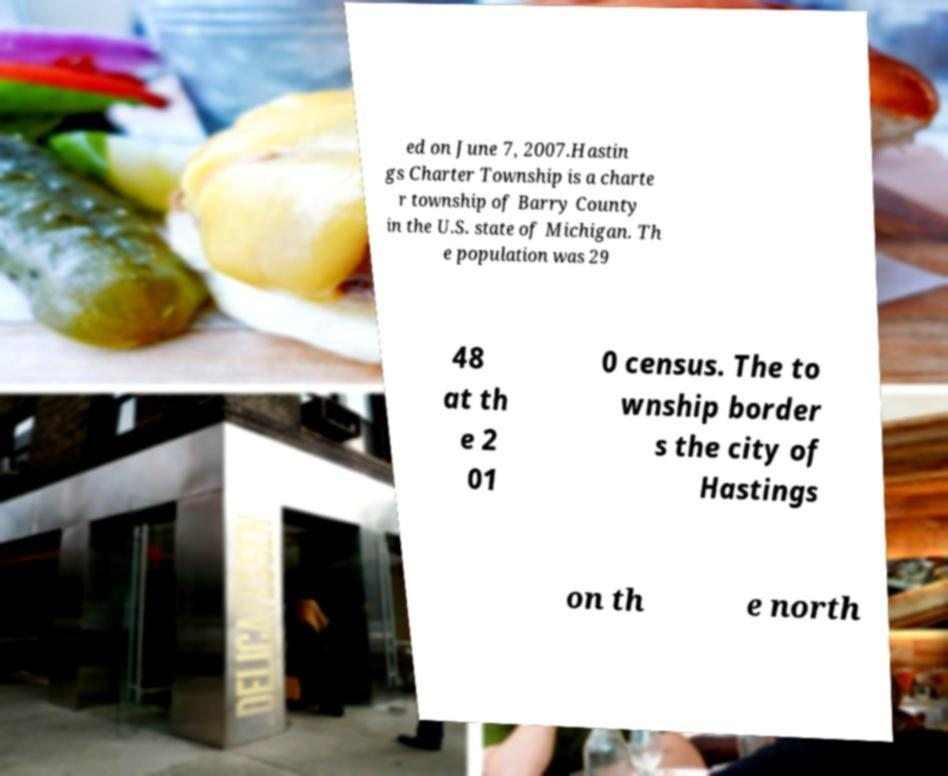There's text embedded in this image that I need extracted. Can you transcribe it verbatim? ed on June 7, 2007.Hastin gs Charter Township is a charte r township of Barry County in the U.S. state of Michigan. Th e population was 29 48 at th e 2 01 0 census. The to wnship border s the city of Hastings on th e north 